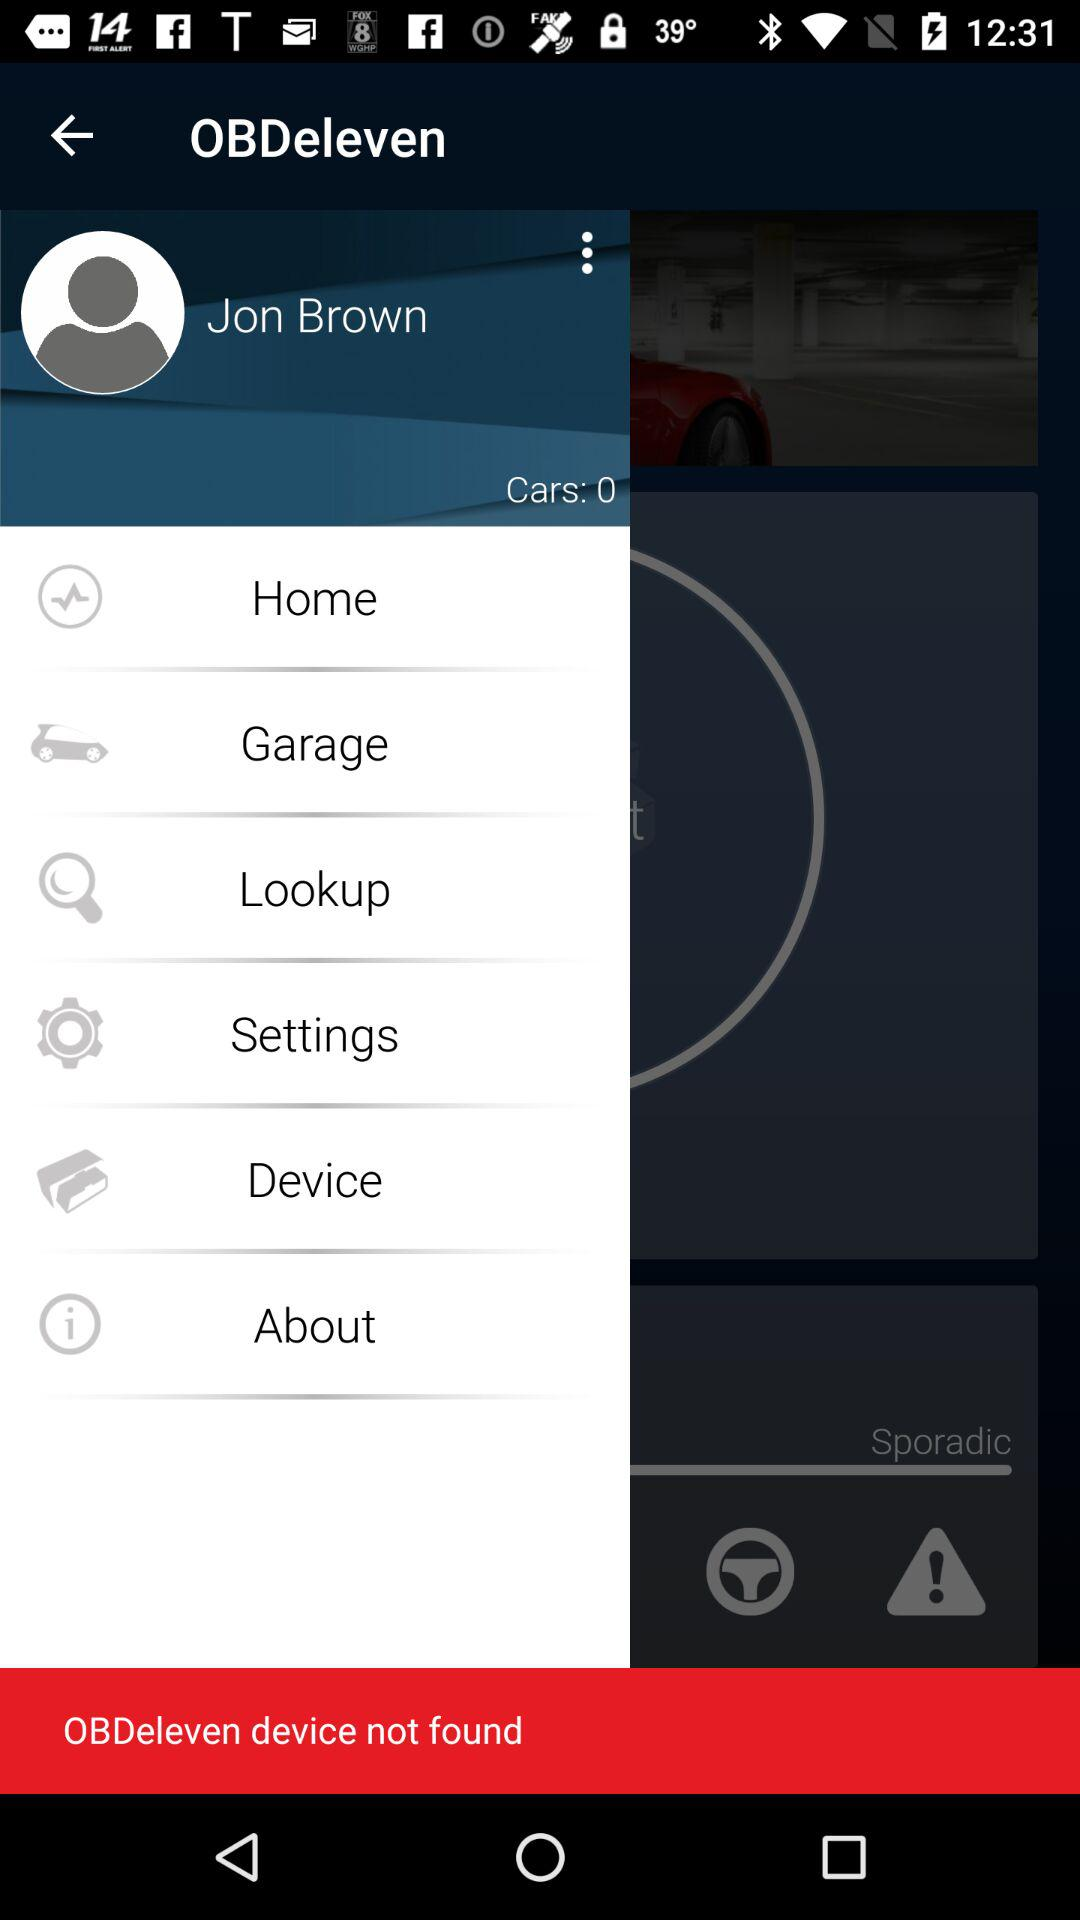What device is not found? The device that is not found is "OBDeleven". 